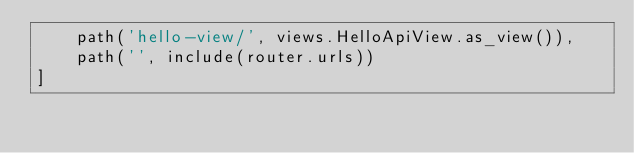<code> <loc_0><loc_0><loc_500><loc_500><_Python_>    path('hello-view/', views.HelloApiView.as_view()),
    path('', include(router.urls))
]
</code> 